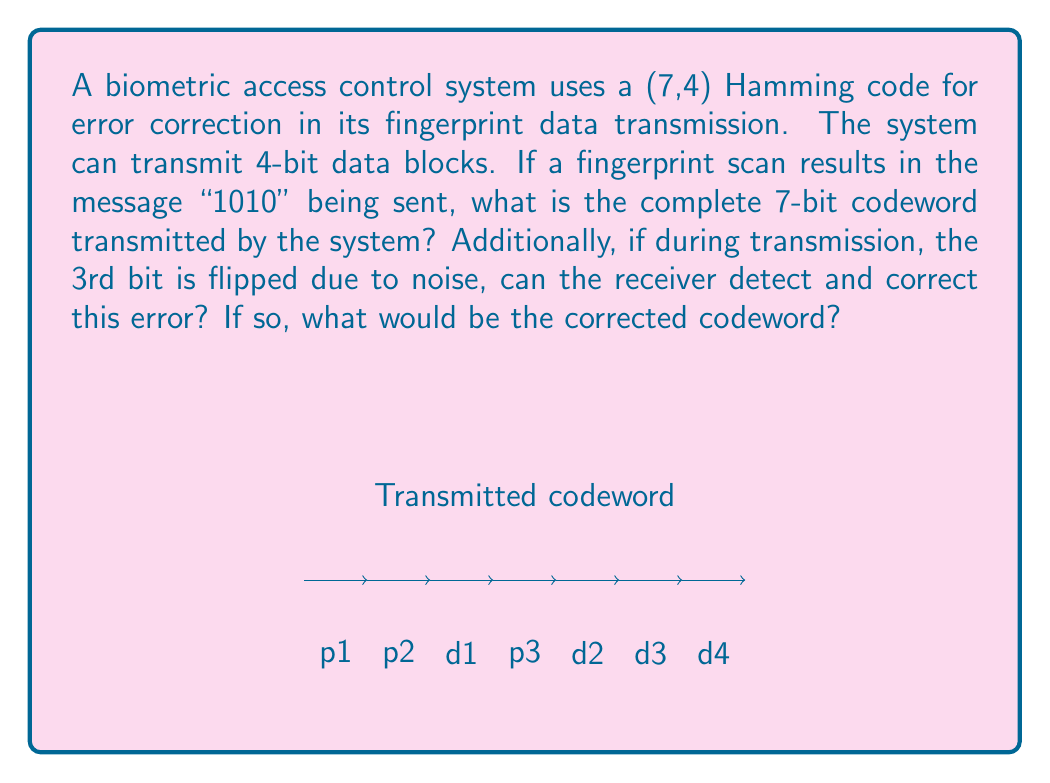Give your solution to this math problem. Let's approach this step-by-step:

1) For a (7,4) Hamming code, we have 7 bits total, with 4 data bits and 3 parity bits.

2) The data bits are "1010". We need to calculate the parity bits.

3) The parity bits are calculated as follows:
   $p_1 = d_1 \oplus d_2 \oplus d_4$
   $p_2 = d_1 \oplus d_3 \oplus d_4$
   $p_3 = d_2 \oplus d_3 \oplus d_4$

   Where $\oplus$ represents XOR operation.

4) Calculating each parity bit:
   $p_1 = 1 \oplus 0 \oplus 0 = 1$
   $p_2 = 1 \oplus 1 \oplus 0 = 0$
   $p_3 = 0 \oplus 1 \oplus 0 = 1$

5) The complete codeword is therefore: 1011010

6) If the 3rd bit is flipped, the received codeword would be: 1001010

7) To detect and correct errors, we calculate the syndrome:
   $s_1 = p_1 \oplus d_1 \oplus d_2 \oplus d_4 = 1 \oplus 1 \oplus 0 \oplus 0 = 0$
   $s_2 = p_2 \oplus d_1 \oplus d_3 \oplus d_4 = 0 \oplus 1 \oplus 1 \oplus 0 = 0$
   $s_3 = p_3 \oplus d_2 \oplus d_3 \oplus d_4 = 1 \oplus 0 \oplus 1 \oplus 0 = 0$

8) The syndrome (001) indicates an error in the 3rd bit position.

9) Correcting this error gives us back the original codeword: 1011010

Therefore, the system can detect and correct this single-bit error.
Answer: Transmitted codeword: 1011010; Error corrected: Yes; Corrected codeword: 1011010 